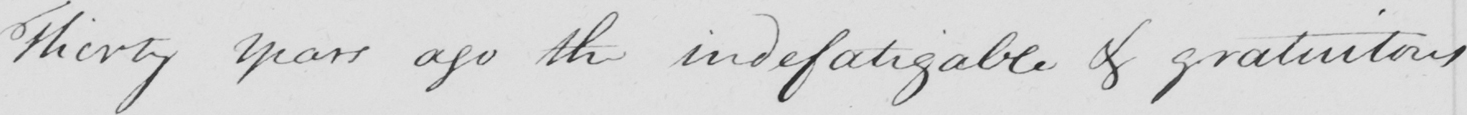Can you tell me what this handwritten text says? Thirty years ago the indefatigable & gratuitous 